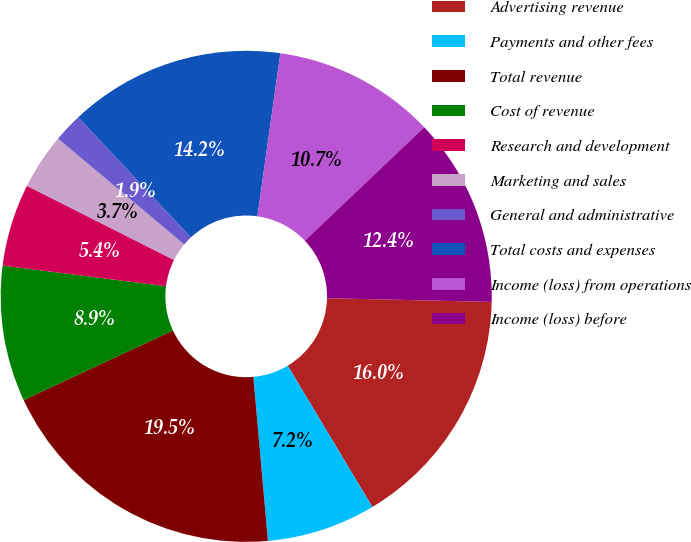<chart> <loc_0><loc_0><loc_500><loc_500><pie_chart><fcel>Advertising revenue<fcel>Payments and other fees<fcel>Total revenue<fcel>Cost of revenue<fcel>Research and development<fcel>Marketing and sales<fcel>General and administrative<fcel>Total costs and expenses<fcel>Income (loss) from operations<fcel>Income (loss) before<nl><fcel>16.05%<fcel>7.18%<fcel>19.47%<fcel>8.94%<fcel>5.43%<fcel>3.67%<fcel>1.91%<fcel>14.21%<fcel>10.69%<fcel>12.45%<nl></chart> 